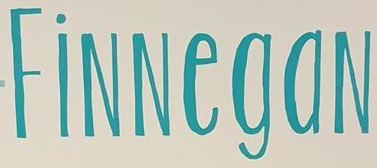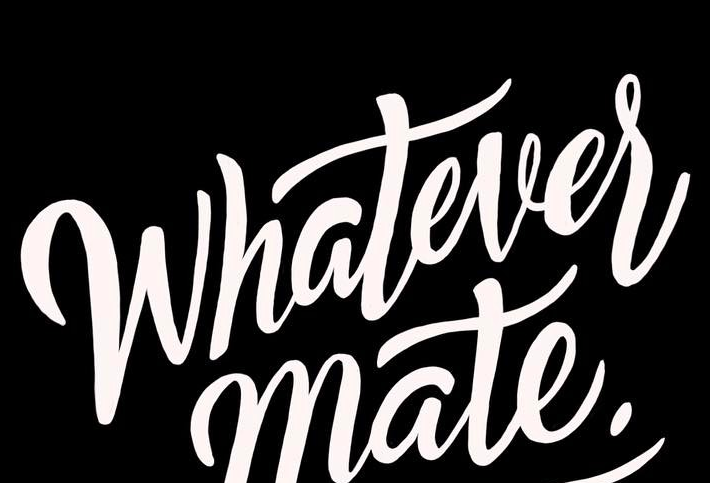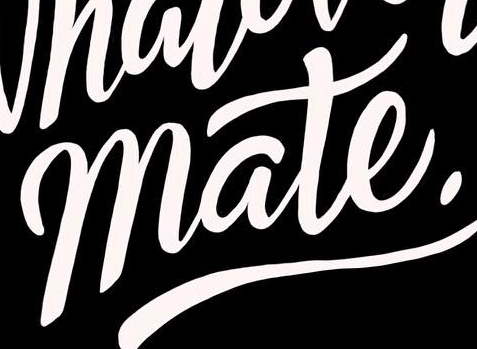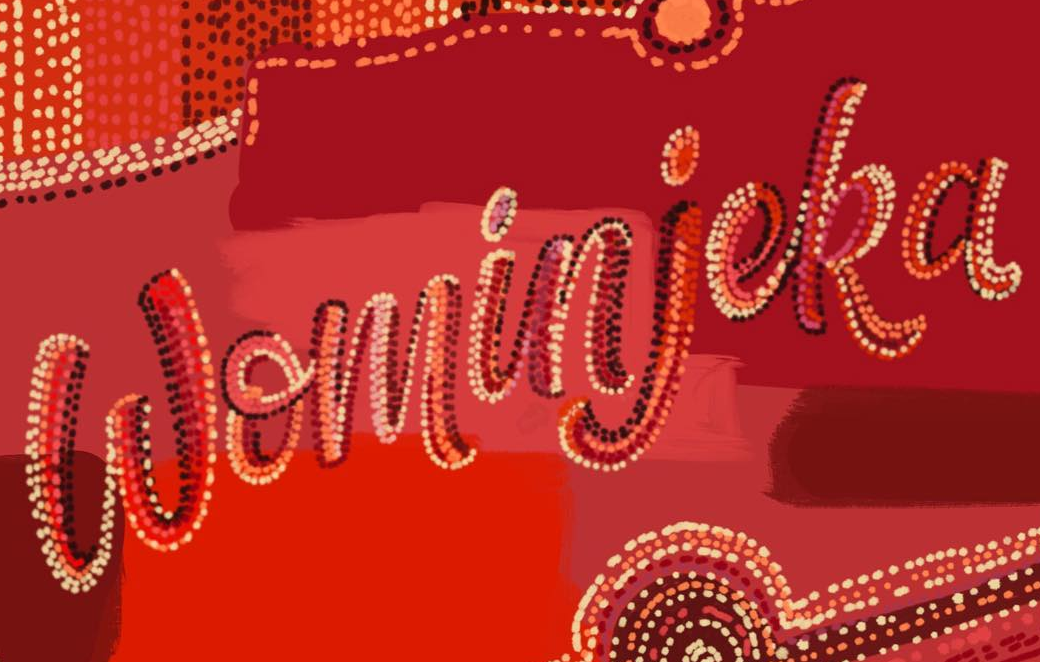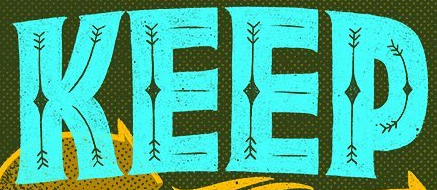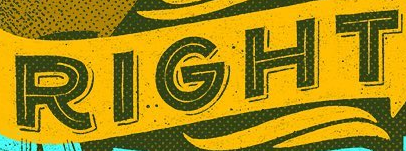What words can you see in these images in sequence, separated by a semicolon? FiNNegaN; Whatever; mate.; Wominjeka; KEEP; RIGHT 